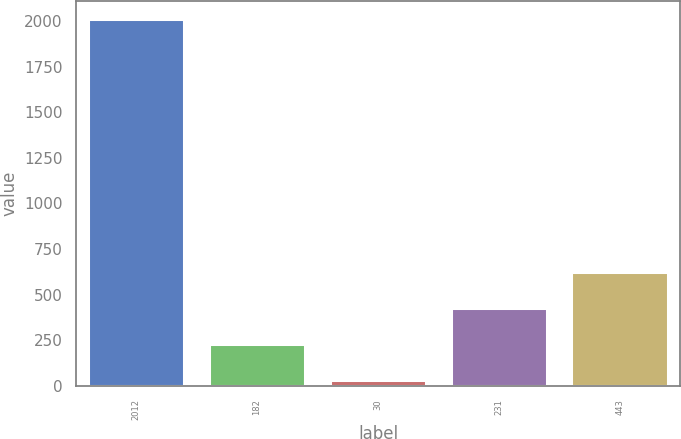Convert chart. <chart><loc_0><loc_0><loc_500><loc_500><bar_chart><fcel>2012<fcel>182<fcel>30<fcel>231<fcel>443<nl><fcel>2011<fcel>229<fcel>31<fcel>427<fcel>625<nl></chart> 